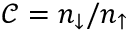<formula> <loc_0><loc_0><loc_500><loc_500>{ \mathcal { C } } = n _ { \downarrow } / n _ { \uparrow }</formula> 